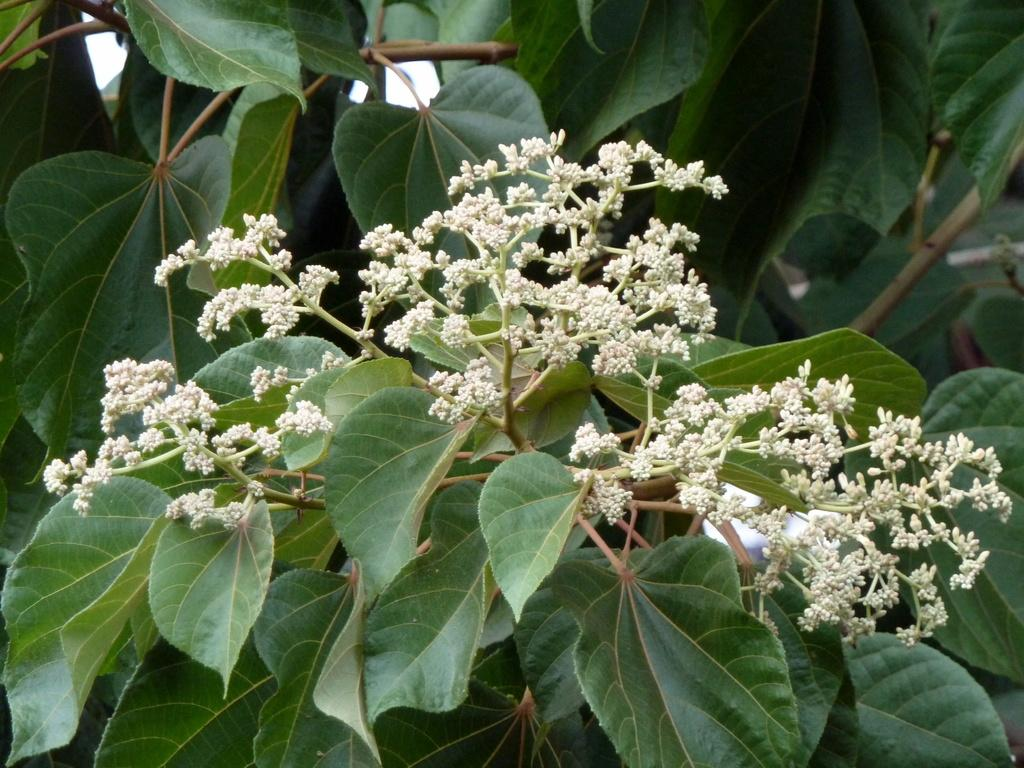What type of vegetation can be seen in the image? There are leaves and flowers in the image. Can you describe the flowers in the image? Unfortunately, the facts provided do not give specific details about the flowers. However, we can confirm that flowers are present in the image. How many houses can be seen in the image? There are no houses present in the image; it features leaves and flowers. What type of pencil is being used to draw the flowers in the image? There is no pencil or drawing activity depicted in the image; it simply shows leaves and flowers. 